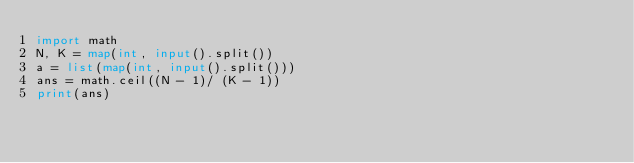<code> <loc_0><loc_0><loc_500><loc_500><_Python_>import math
N, K = map(int, input().split())
a = list(map(int, input().split()))
ans = math.ceil((N - 1)/ (K - 1))
print(ans)</code> 